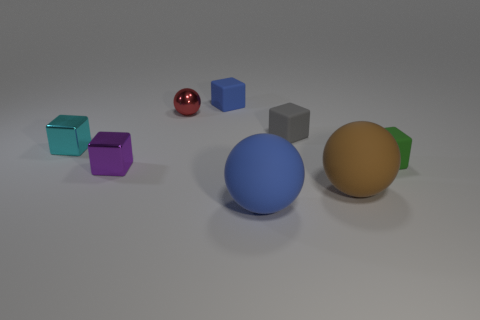Subtract all tiny cyan shiny blocks. How many blocks are left? 4 Subtract 2 cubes. How many cubes are left? 3 Subtract all gray cubes. How many cubes are left? 4 Subtract all cubes. How many objects are left? 3 Add 1 gray rubber cubes. How many objects exist? 9 Subtract 0 green balls. How many objects are left? 8 Subtract all yellow cubes. Subtract all purple cylinders. How many cubes are left? 5 Subtract all yellow cylinders. How many cyan blocks are left? 1 Subtract all big spheres. Subtract all small green matte cubes. How many objects are left? 5 Add 2 large matte things. How many large matte things are left? 4 